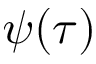Convert formula to latex. <formula><loc_0><loc_0><loc_500><loc_500>\psi ( \tau )</formula> 